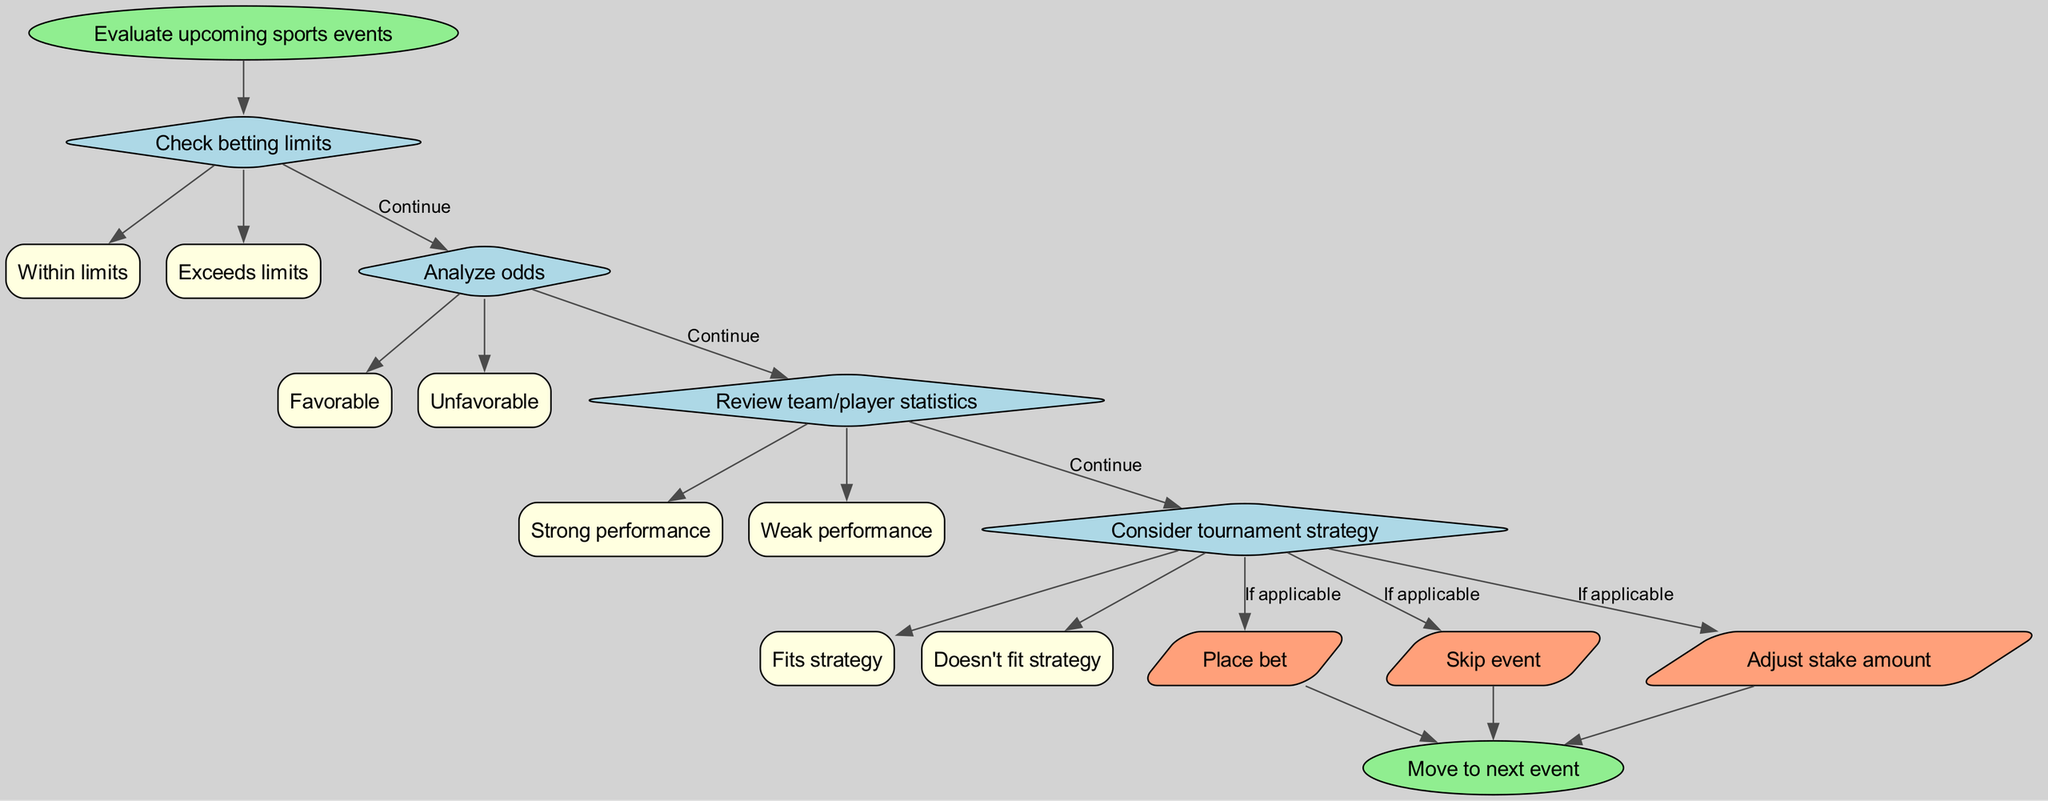What is the starting point of the decision-making process? The starting point, as indicated in the diagram, is "Evaluate upcoming sports events." This is the first node from which the decision-making process begins.
Answer: Evaluate upcoming sports events How many decision points are present in the diagram? The diagram features four decision points, each representing a stage in the decision-making process before arriving at any actions. These are about betting limits, odds analysis, team/player statistics, and tournament strategy.
Answer: 4 What are the two options available after checking betting limits? After checking betting limits, the two options available are "Within limits" and "Exceeds limits." These options represent the possible outcomes of this decision point in the flowchart.
Answer: Within limits, Exceeds limits What action should be taken if the overall performance of the team/player is strong? If the team/player shows strong performance, the flowchart suggests that a bet should be placed. This action is linked to the decision point regarding reviewing statistics.
Answer: Place bet What is the final outcome of the decision-making process? The final outcome, as indicated in the diagram, is to "Move to next event." This signifies the conclusion of the process after the actions are taken.
Answer: Move to next event What action follows if the analysis of odds is unfavorable? If the analysis of odds is unfavorable, the appropriate action according to the diagram is to skip the event. This step is based on the decision made after evaluating the odds.
Answer: Skip event Which decision point leads directly to placing a bet? Placing a bet follows from both checking betting limits and analyzing odds being favorable as decision points, leading to the action of placing the bet. The relationships are established through the flowchart's progression.
Answer: Checking betting limits, Analyzing odds What happens if the tournament strategy does not fit? If the tournament strategy does not fit, according to the diagram, the likely action is to skip the event as per the flow of the decision-making process outlined in that scenario.
Answer: Skip event 